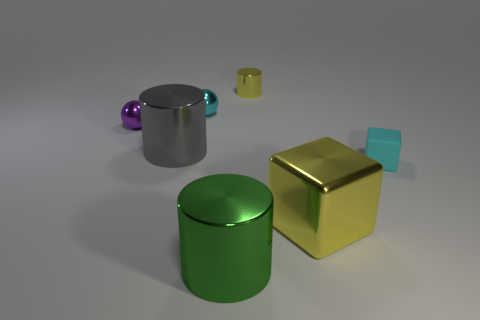Subtract all big cylinders. How many cylinders are left? 1 Subtract 1 cylinders. How many cylinders are left? 2 Add 2 purple objects. How many objects exist? 9 Subtract all purple cylinders. Subtract all green cubes. How many cylinders are left? 3 Subtract all cubes. How many objects are left? 5 Subtract all tiny purple shiny objects. Subtract all small metal cylinders. How many objects are left? 5 Add 1 tiny metal spheres. How many tiny metal spheres are left? 3 Add 1 small cyan objects. How many small cyan objects exist? 3 Subtract 0 green blocks. How many objects are left? 7 